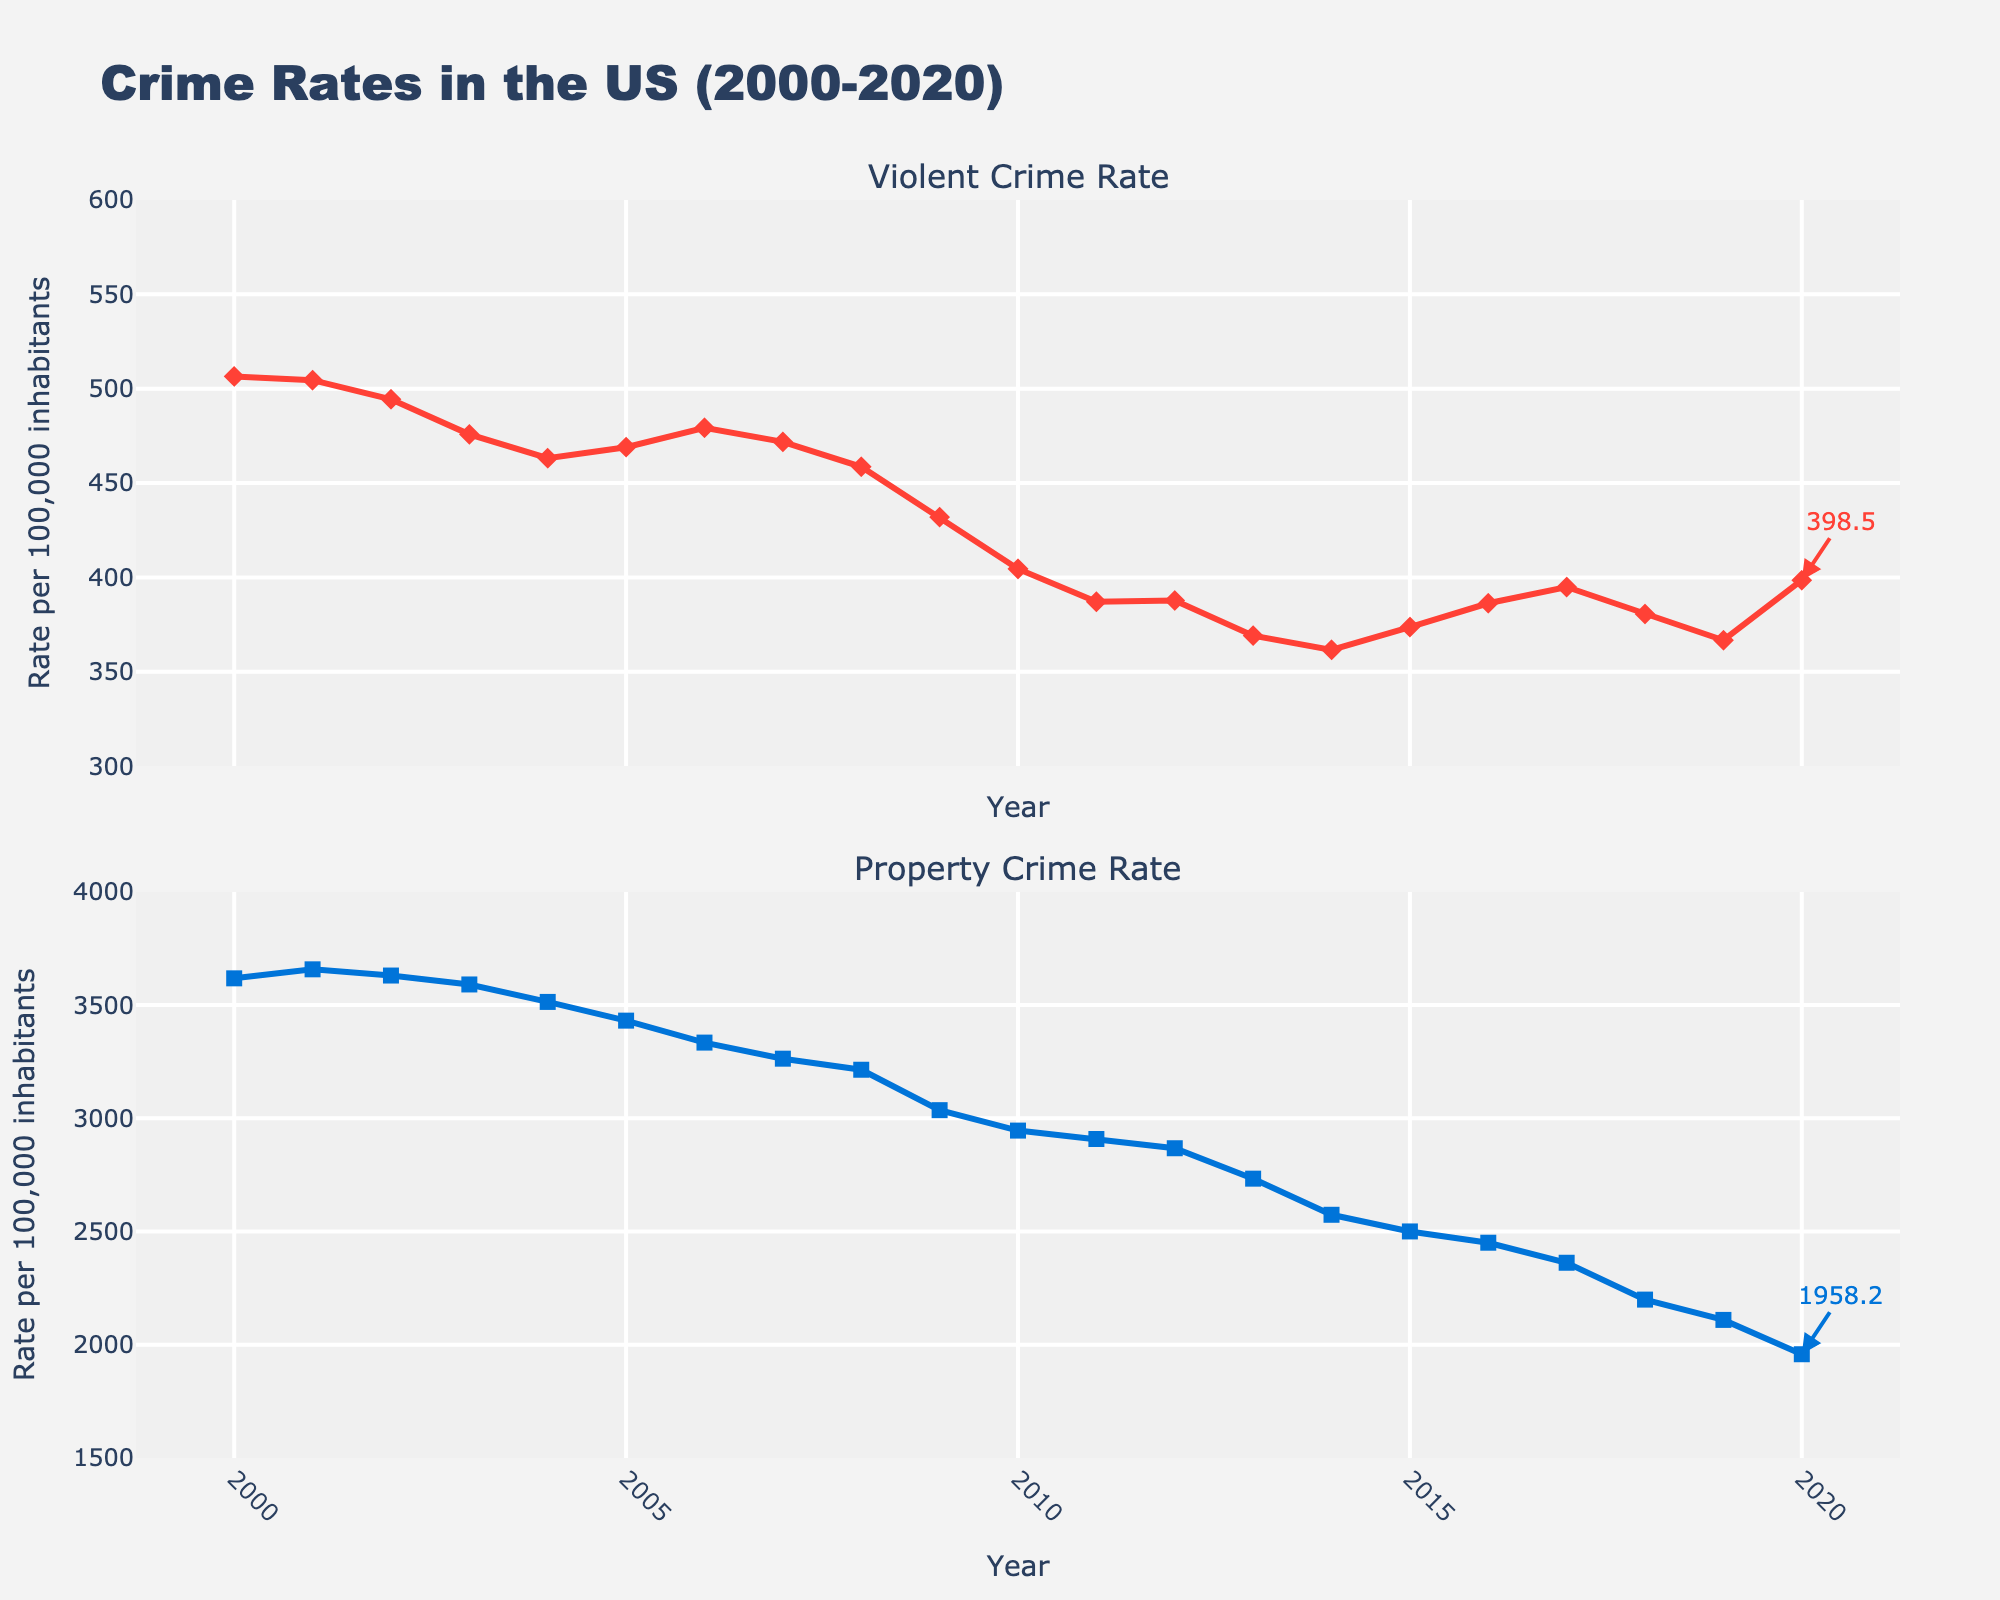What is the overall trend in violent crime rates over the 20-year period? The violent crime rate starts at approximately 506.5 per 100,000 inhabitants in 2000 and fluctuates before ultimately decreasing to around 398.5 in 2020. The general trend indicates a decline in violent crime rates over the 20-year period.
Answer: Decline How do the property crime rates in 2000 compare to those in 2020? In 2000, the property crime rate is approximately 3618.3 per 100,000 inhabitants, and by 2020 it has decreased to around 1958.2. This shows a significant reduction in property crime rates over the 20 years.
Answer: Lower in 2020 By how much did the violent crime rate change from 2000 to 2020? The violent crime rate in 2000 is approximately 506.5, and in 2020 it is around 398.5. The change can be calculated as 506.5 - 398.5 = 108. The violent crime rate decreased by 108 per 100,000 inhabitants.
Answer: Decreased by 108 Between which years did the property crime rate experience the steepest decline? By visually inspecting the slope of the lines, the steepest decline in property crime rates can be seen between the years 2008 and 2009, where the rate drops from about 3214.6 to 3036.1, a decline of approximately 178.5 per 100,000 inhabitants.
Answer: 2008 to 2009 What was the average property crime rate from 2010 to 2015? To determine the average, sum the property crime rates from 2010 (2945.9), 2011 (2908.7), 2012 (2868.0), 2013 (2733.6), 2014 (2574.1), and 2015 (2500.5) then divide by 6. (2945.9 + 2908.7 + 2868.0 + 2733.6 + 2574.1 + 2500.5) / 6 = 2755.13
Answer: 2755.13 In which year was the property crime rate closest to 2000 per 100,000 inhabitants? Inspecting the lines, the property crime rate closest to 2000 per 100,000 inhabitants is in 2010, where the rate is 2005.8.
Answer: 2010 What is the difference between the highest and the lowest violent crime rates shown in the figure? The highest violent crime rate is in 2000 at approximately 506.5 per 100,000 inhabitants, and the lowest is in 2014 at around 361.6. The difference is calculated as 506.5 - 361.6 = 144.9.
Answer: 144.9 Which crime rate had a higher decrease percentage from 2000 to 2020, violent crime or property crime? The decrease in violent crime from 506.5 to 398.5 is (506.5 - 398.5) / 506.5 * 100 = 21.3%. The decrease in property crime from 3618.3 to 1958.2 is (3618.3 - 1958.2) / 3618.3 * 100 = 45.9%. The property crime rate had a higher decrease percentage.
Answer: Property crime Did violent crime rate ever increase two consecutive years? From the chart, the violent crime rate increased consecutively in 2004 and 2005 (463.2 in 2004 and 469.0 in 2005).
Answer: Yes How much did the property crime rate decrease from its highest point to the lowest point shown in the plot? The highest point is approximately 3658.1 in 2001 and the lowest point is 1958.2 in 2020. The decrease is calculated as 3658.1 - 1958.2 = 1699.9.
Answer: 1699.9 